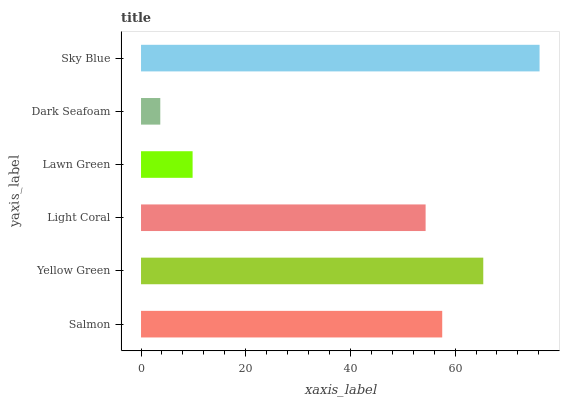Is Dark Seafoam the minimum?
Answer yes or no. Yes. Is Sky Blue the maximum?
Answer yes or no. Yes. Is Yellow Green the minimum?
Answer yes or no. No. Is Yellow Green the maximum?
Answer yes or no. No. Is Yellow Green greater than Salmon?
Answer yes or no. Yes. Is Salmon less than Yellow Green?
Answer yes or no. Yes. Is Salmon greater than Yellow Green?
Answer yes or no. No. Is Yellow Green less than Salmon?
Answer yes or no. No. Is Salmon the high median?
Answer yes or no. Yes. Is Light Coral the low median?
Answer yes or no. Yes. Is Dark Seafoam the high median?
Answer yes or no. No. Is Lawn Green the low median?
Answer yes or no. No. 